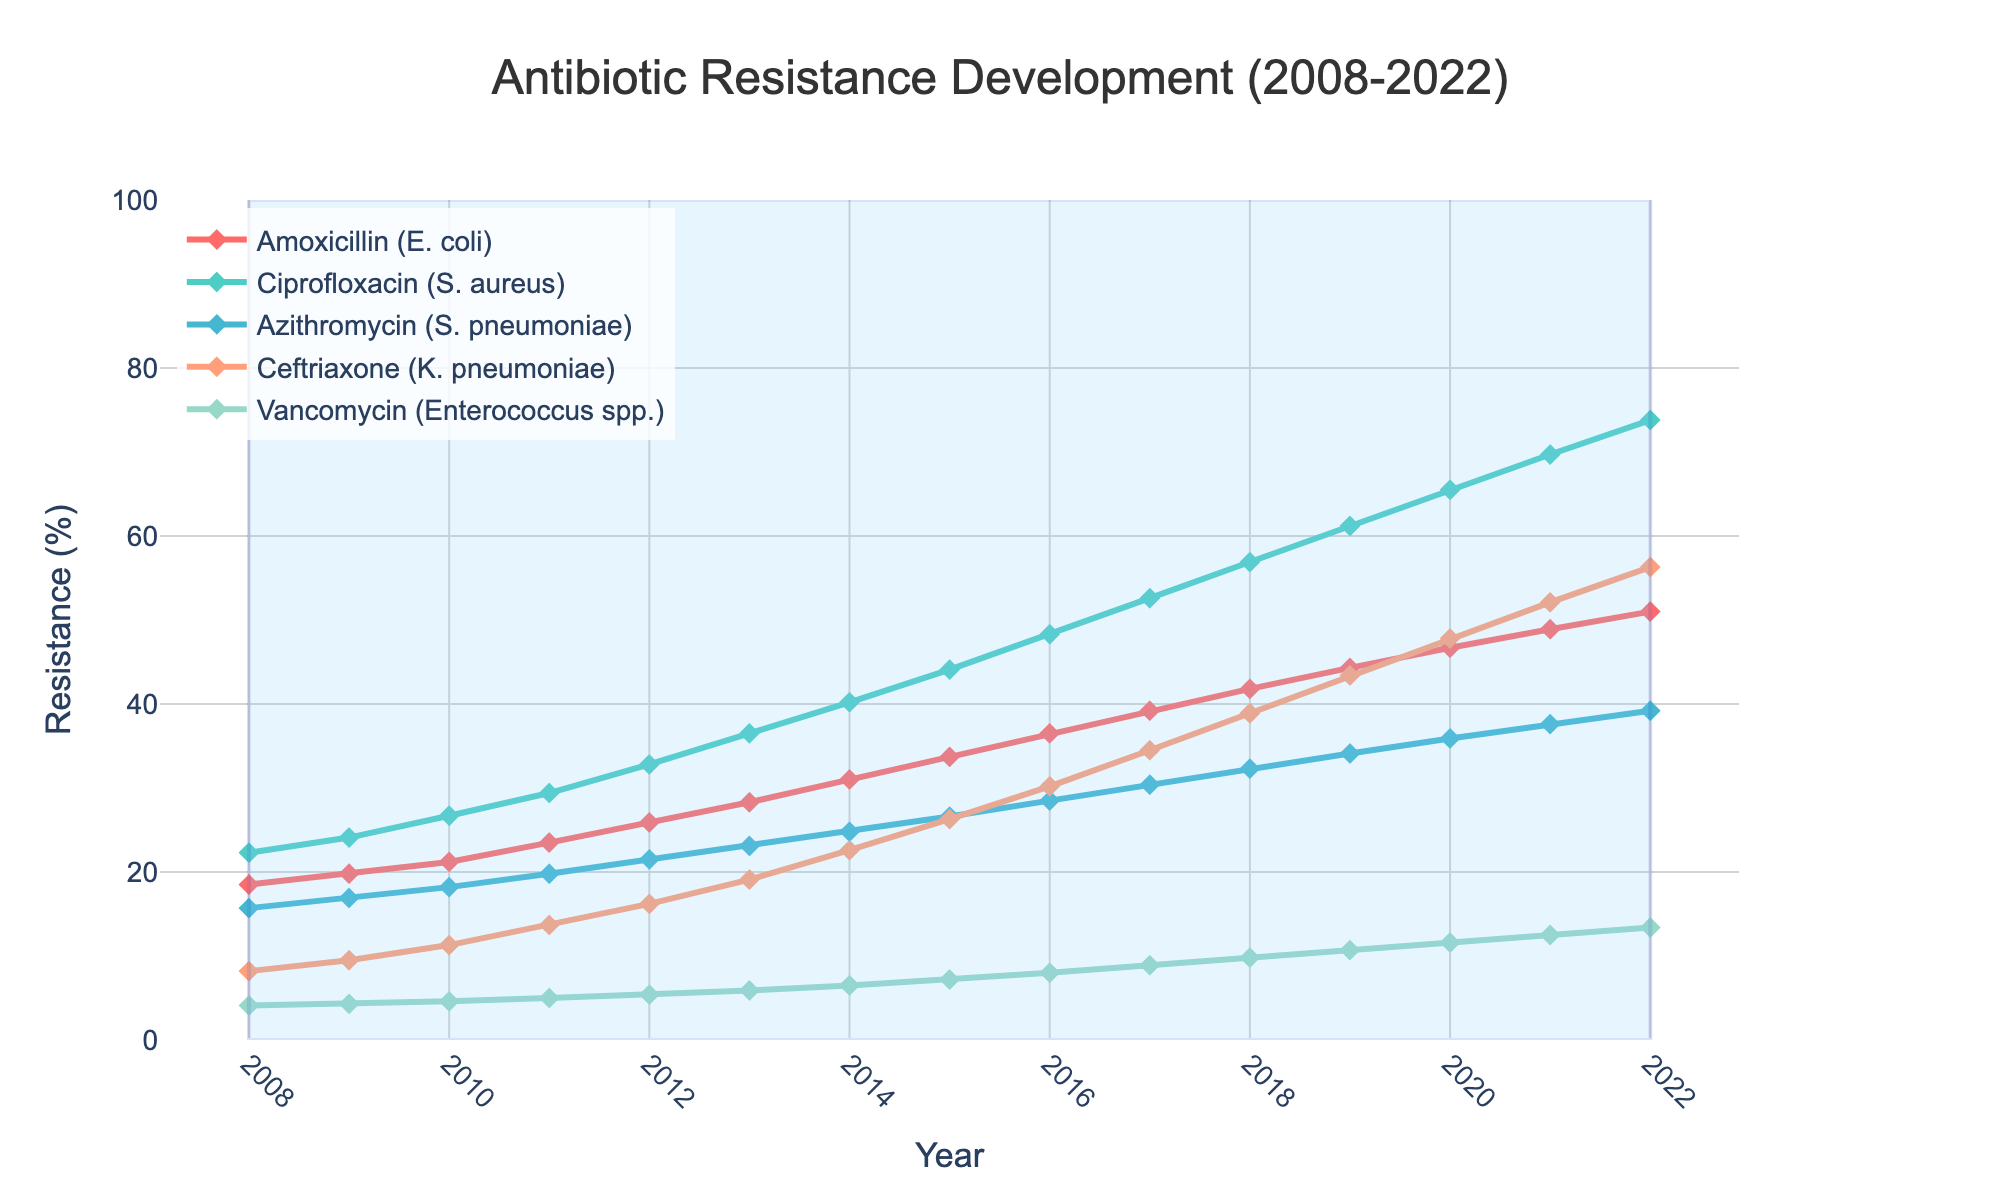Which antibiotic class had the highest resistance rate in 2022? From the chart, locate the data points corresponding to the year 2022 and find the highest y-value among the antibiotic classes.
Answer: Ciprofloxacin (S. aureus) What was the increase in resistance percentage for Amoxicillin (E. coli) from 2008 to 2022? Subtract the percentage resistance in 2008 from the percentage resistance in 2022 for Amoxicillin (E. coli): 51.0 - 18.5.
Answer: 32.5 Between 2010 and 2020, which antibiotic class showed the largest absolute increase in resistance? Calculate the difference in resistance percentages for each antibiotic class between 2010 and 2020, then determine which class has the largest value.
Answer: Ceftriaxone (K. pneumoniae) Did any of the antibiotic classes have a resistance percentage exceeding 50% before 2015? Check the resistance percentages for all antibiotic classes year by year up to 2014 to see if any crossed the 50% threshold.
Answer: No Compare the resistance rates of Azithromycin (S. pneumoniae) and Vancomycin (Enterococcus spp.) in 2017. Which is higher and by how much? Locate the resistance percentages for both antibiotics in 2017 and subtract the Vancomycin value from the Azithromycin value: 30.4 - 8.9.
Answer: Azithromycin is higher by 21.5 What trend is observed for Vancomycin (Enterococcus spp.) from 2010 to 2020? Examine the data points for Vancomycin from 2010 to 2020, noting whether they increase, decrease, or remain stable over the period.
Answer: Increasing How does the resistance rate of Ceftriaxone (K. pneumoniae) in 2015 compare to that of Ciprofloxacin (S. aureus) in the same year? Locate the resistance percentages of both antibiotics in 2015 and compare them directly.
Answer: Ceftriaxone is lower Which two antibiotic classes had the closest resistance percentage in 2021, and what were those rates? Identify the resistance percentages for all antibiotic classes in 2021, then find the two classes with the smallest difference between their values.
Answer: Ceftriaxone (52.1) and Vancomycin (12.5) How did the resistance rate of Amoxicillin (E. coli) change from 2013 to 2018? Subtract the resistance percentage of Amoxicillin (E. coli) in 2013 from that in 2018: 41.8 - 28.3.
Answer: Increased by 13.5 